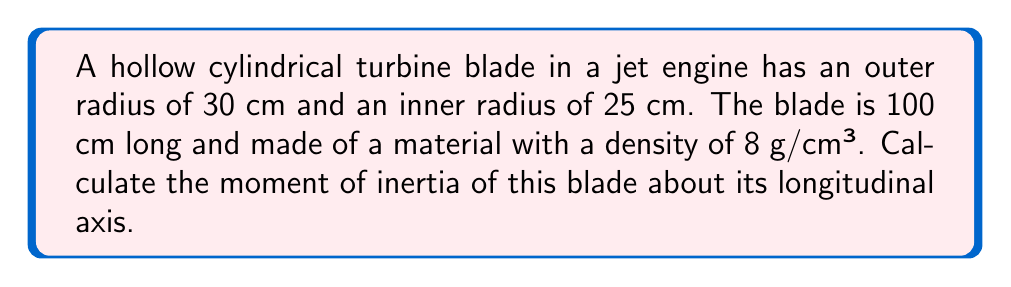Teach me how to tackle this problem. To solve this problem, we'll follow these steps:

1) The moment of inertia for a hollow cylinder about its longitudinal axis is given by the formula:

   $$I = \frac{1}{2}m(r_o^2 + r_i^2)$$

   where $m$ is the mass, $r_o$ is the outer radius, and $r_i$ is the inner radius.

2) First, we need to calculate the mass of the blade. The volume of a hollow cylinder is:

   $$V = \pi(r_o^2 - r_i^2)h$$

   where $h$ is the length of the cylinder.

3) Let's calculate the volume:

   $$V = \pi((30\text{ cm})^2 - (25\text{ cm})^2) \times 100\text{ cm} = 8250\pi\text{ cm}^3$$

4) Now we can calculate the mass:

   $$m = \rho V = 8\text{ g/cm}^3 \times 8250\pi\text{ cm}^3 = 66000\pi\text{ g} = 66\pi\text{ kg}$$

5) Now we have all the components to calculate the moment of inertia:

   $$I = \frac{1}{2}(66\pi\text{ kg})((0.30\text{ m})^2 + (0.25\text{ m})^2)$$

6) Simplifying:

   $$I = 33\pi(0.09 + 0.0625)\text{ kg}\cdot\text{m}^2 = 33\pi(0.1525)\text{ kg}\cdot\text{m}^2 = 5.0325\pi\text{ kg}\cdot\text{m}^2$$
Answer: $5.0325\pi\text{ kg}\cdot\text{m}^2$ 